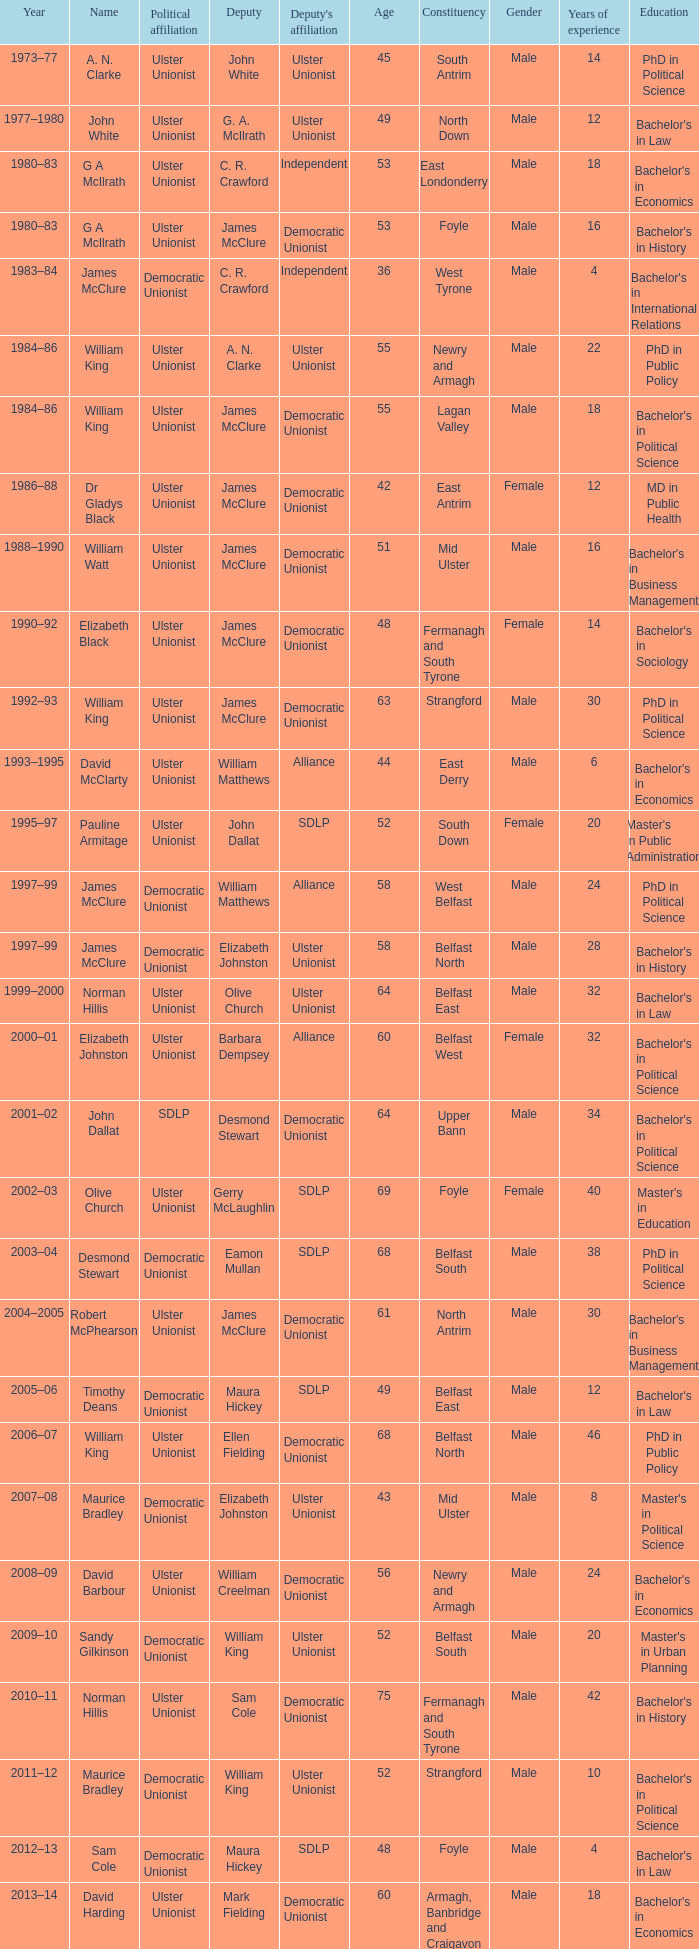What Year was james mcclure Deputy, and the Name is robert mcphearson? 2004–2005. 